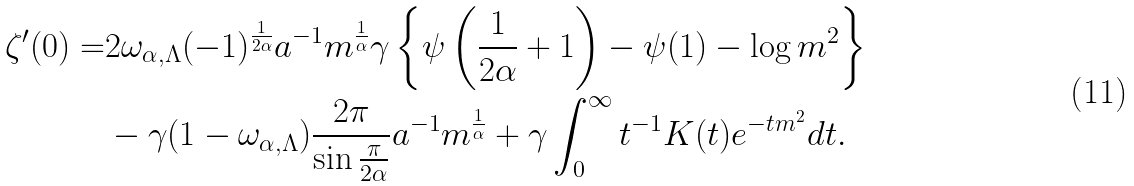<formula> <loc_0><loc_0><loc_500><loc_500>\zeta ^ { \prime } ( 0 ) = & 2 \omega _ { \alpha , \Lambda } ( - 1 ) ^ { \frac { 1 } { 2 \alpha } } a ^ { - 1 } m ^ { \frac { 1 } { \alpha } } \gamma \left \{ \psi \left ( \frac { 1 } { 2 \alpha } + 1 \right ) - \psi ( 1 ) - \log m ^ { 2 } \right \} \\ & - \gamma ( 1 - \omega _ { \alpha , \Lambda } ) \frac { 2 \pi } { \sin \frac { \pi } { 2 \alpha } } a ^ { - 1 } m ^ { \frac { 1 } { \alpha } } + \gamma \int _ { 0 } ^ { \infty } t ^ { - 1 } K ( t ) e ^ { - t m ^ { 2 } } d t .</formula> 